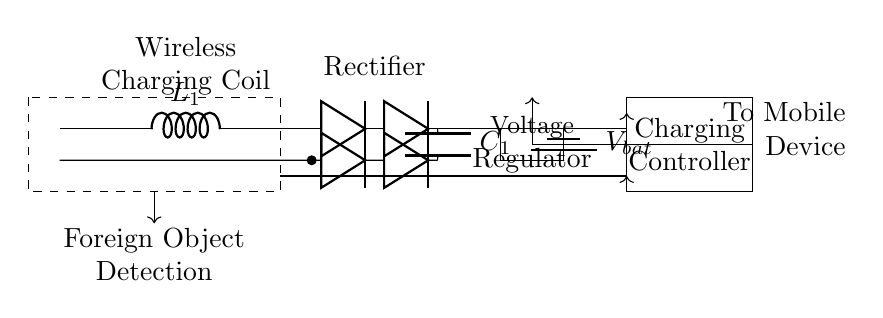What type of coil is used in this circuit? The circuit diagram labels the coil as a "Wireless Charging Coil," specifically denoted as L1. This indicates its role in the wireless charging process.
Answer: Wireless Charging Coil What is the function of the smoothing capacitor? The smoothing capacitor, labeled C1 in the circuit, serves to smooth the output voltage from the rectifier by filtering out fluctuations, ensuring a stable voltage supply to subsequent components.
Answer: Filter voltage What does the dashed box in the circuit represent? The dashed rectangle encloses the "Foreign Object Detection" feature. This denotes that the circuit includes a mechanism to identify any foreign objects that may interfere with the charging process, enhancing safety.
Answer: Foreign Object Detection Which component regulates the voltage to the battery? The voltage regulator, indicated by the rectangle labeled "Voltage Regulator," manages and stabilizes the voltage being supplied to the battery, ensuring it operates within its safe range.
Answer: Voltage Regulator What is the purpose of the charging controller in this circuit? The charging controller, identified as the rectangle labeled "Charging Controller," coordinates the charging process by managing how power is directed to the mobile device, ensuring efficient charging while preventing damage.
Answer: Manage charging How many diodes are used in the rectifier section? The diagram depicts a total of four diodes in the rectifier section, two positioned in a forward-biased manner and two in a reverse-biased manner, which are used to convert alternating current to direct current for charging.
Answer: Four diodes What is the relationship between the foreign object detection and charging controller? The foreign object detection is crucial for the charging controller to function safely; it allows the controller to suspend or stop charging when an obstruction is detected, protecting both the mobile device and the user.
Answer: Safety feature 